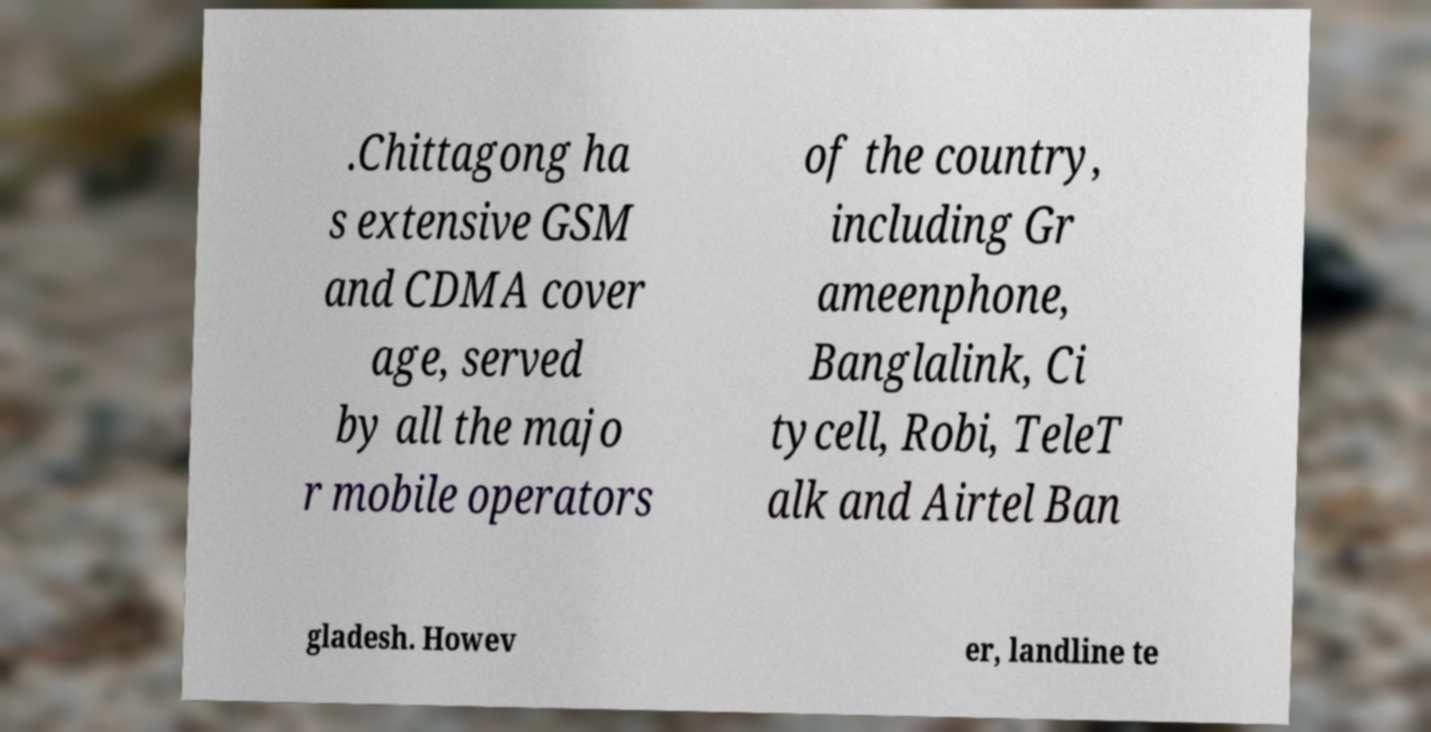Can you accurately transcribe the text from the provided image for me? .Chittagong ha s extensive GSM and CDMA cover age, served by all the majo r mobile operators of the country, including Gr ameenphone, Banglalink, Ci tycell, Robi, TeleT alk and Airtel Ban gladesh. Howev er, landline te 